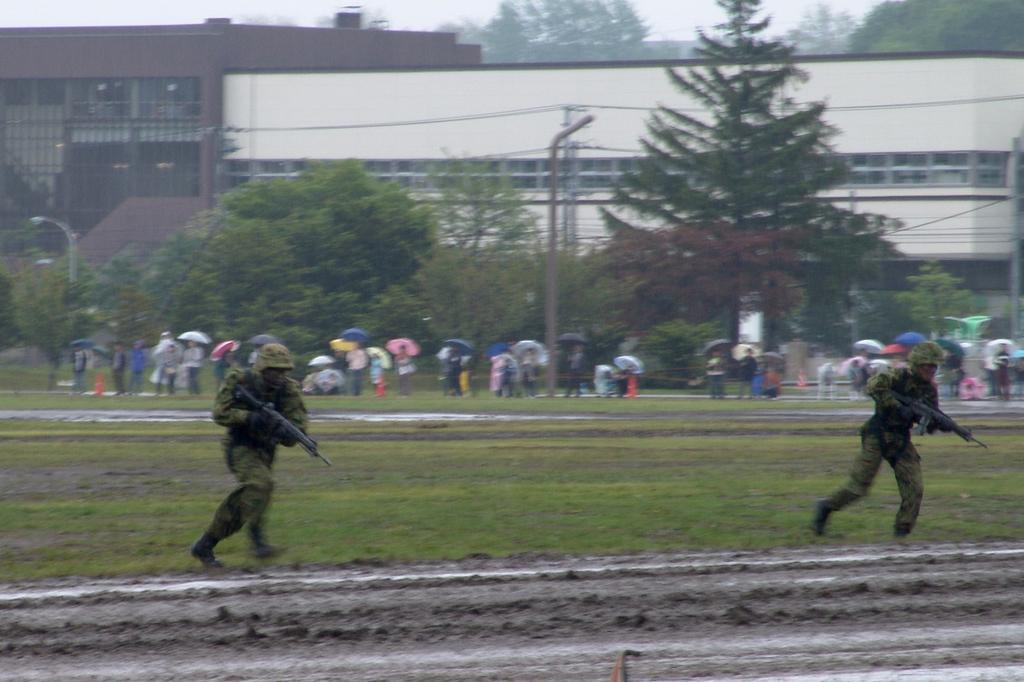Please provide a concise description of this image. In this image I can see an open grass ground where in the front I can see two men are running and holding guns. I can also see both of them are wearing uniforms and helmets. In the background I can see number of trees, few poles, wires, a building, the sky and I can also see number of people are standing and holding umbrellas. On the left side I can see a pole and a light. 